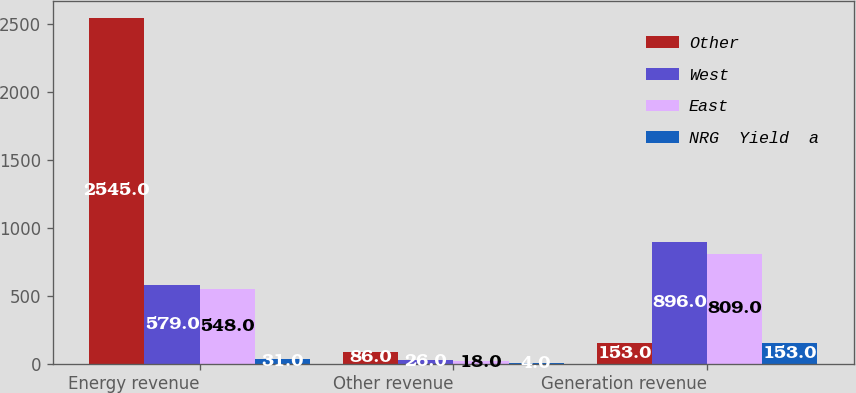Convert chart to OTSL. <chart><loc_0><loc_0><loc_500><loc_500><stacked_bar_chart><ecel><fcel>Energy revenue<fcel>Other revenue<fcel>Generation revenue<nl><fcel>Other<fcel>2545<fcel>86<fcel>153<nl><fcel>West<fcel>579<fcel>26<fcel>896<nl><fcel>East<fcel>548<fcel>18<fcel>809<nl><fcel>NRG  Yield  a<fcel>31<fcel>4<fcel>153<nl></chart> 